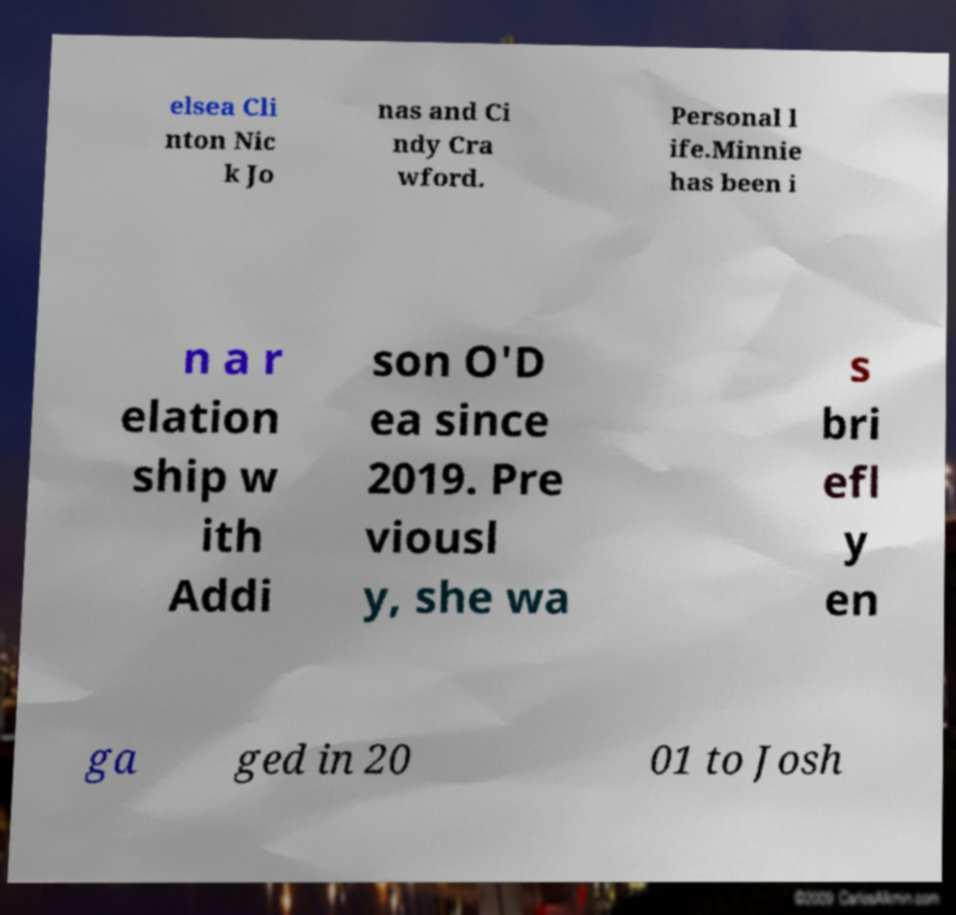There's text embedded in this image that I need extracted. Can you transcribe it verbatim? elsea Cli nton Nic k Jo nas and Ci ndy Cra wford. Personal l ife.Minnie has been i n a r elation ship w ith Addi son O'D ea since 2019. Pre viousl y, she wa s bri efl y en ga ged in 20 01 to Josh 